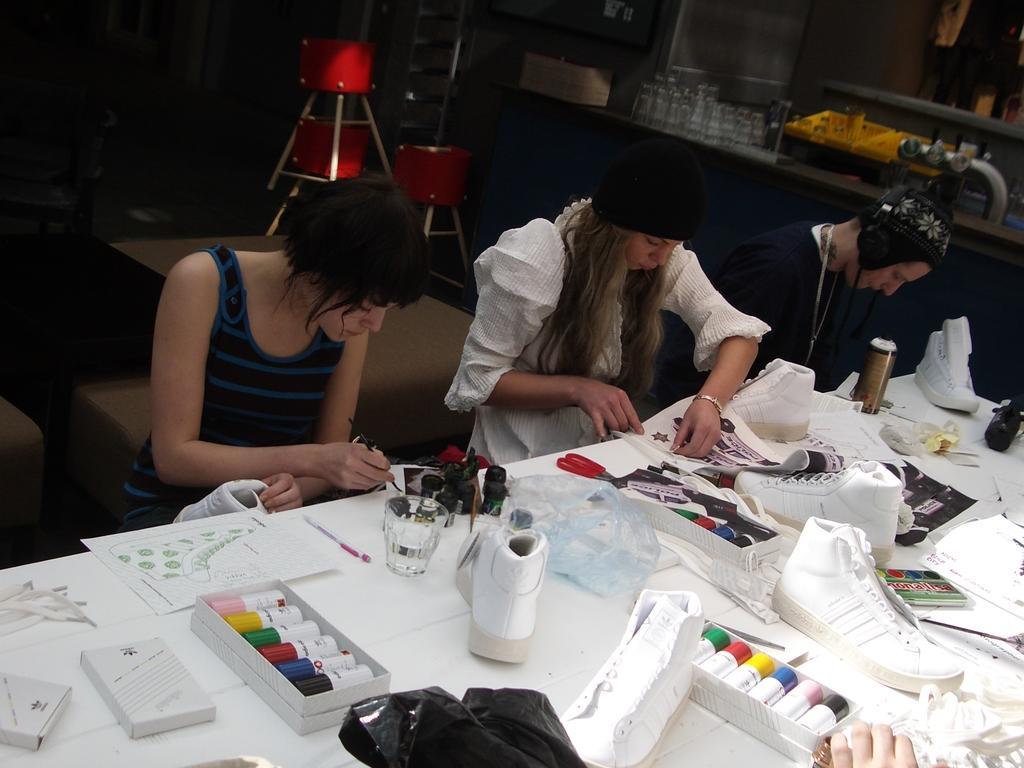Could you give a brief overview of what you see in this image? At the bottom of the image there is a white color table on which there are shoes, colors, glass, scissors and other objects. There are two ladies sitting on the table. Beside them there is a person wearing headphones. In the background of the image there are chairs. To the right side of the image there is a platform on which there are glasses and other objects. 